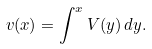<formula> <loc_0><loc_0><loc_500><loc_500>v ( x ) = \int ^ { x } V ( y ) \, d y .</formula> 